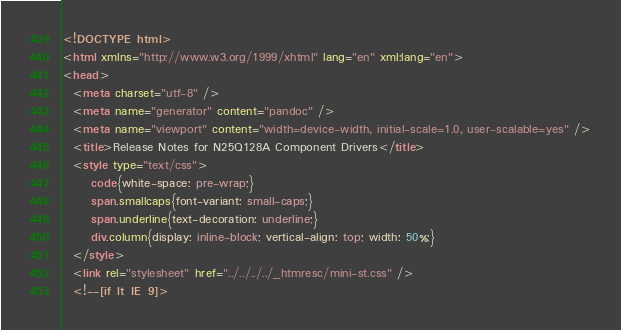<code> <loc_0><loc_0><loc_500><loc_500><_HTML_><!DOCTYPE html>
<html xmlns="http://www.w3.org/1999/xhtml" lang="en" xml:lang="en">
<head>
  <meta charset="utf-8" />
  <meta name="generator" content="pandoc" />
  <meta name="viewport" content="width=device-width, initial-scale=1.0, user-scalable=yes" />
  <title>Release Notes for N25Q128A Component Drivers</title>
  <style type="text/css">
      code{white-space: pre-wrap;}
      span.smallcaps{font-variant: small-caps;}
      span.underline{text-decoration: underline;}
      div.column{display: inline-block; vertical-align: top; width: 50%;}
  </style>
  <link rel="stylesheet" href="../../../../_htmresc/mini-st.css" />
  <!--[if lt IE 9]></code> 